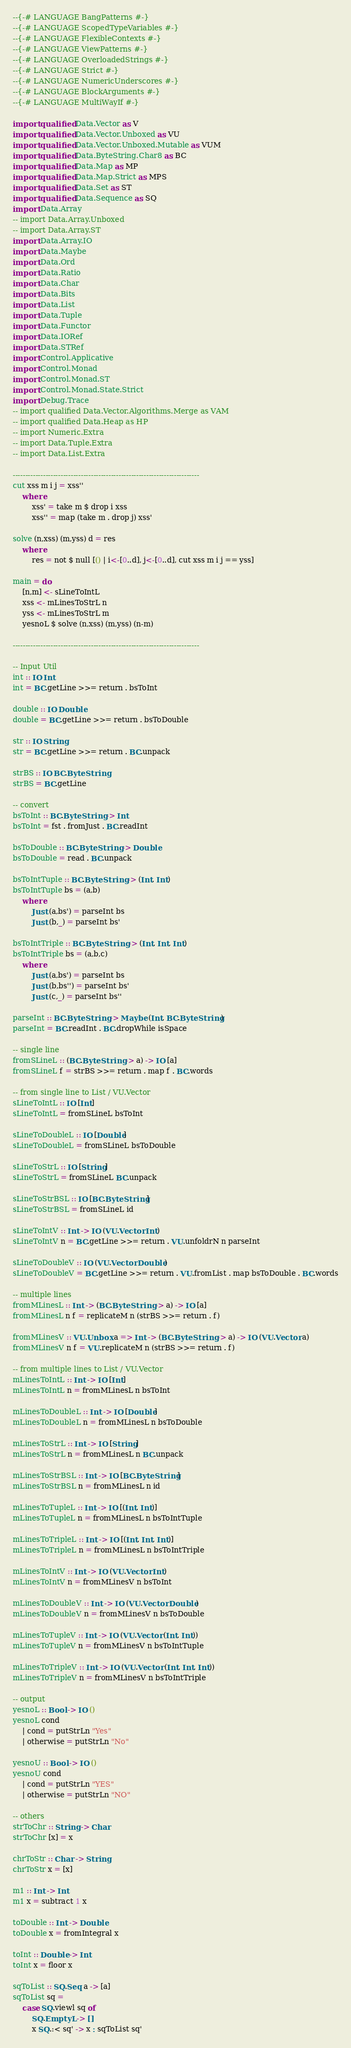<code> <loc_0><loc_0><loc_500><loc_500><_Haskell_>--{-# LANGUAGE BangPatterns #-}
--{-# LANGUAGE ScopedTypeVariables #-}
--{-# LANGUAGE FlexibleContexts #-}
--{-# LANGUAGE ViewPatterns #-}
--{-# LANGUAGE OverloadedStrings #-}
--{-# LANGUAGE Strict #-}
--{-# LANGUAGE NumericUnderscores #-}
--{-# LANGUAGE BlockArguments #-}
--{-# LANGUAGE MultiWayIf #-}

import qualified Data.Vector as V
import qualified Data.Vector.Unboxed as VU
import qualified Data.Vector.Unboxed.Mutable as VUM
import qualified Data.ByteString.Char8 as BC
import qualified Data.Map as MP
import qualified Data.Map.Strict as MPS
import qualified Data.Set as ST
import qualified Data.Sequence as SQ
import Data.Array
-- import Data.Array.Unboxed
-- import Data.Array.ST
import Data.Array.IO
import Data.Maybe
import Data.Ord
import Data.Ratio
import Data.Char
import Data.Bits
import Data.List
import Data.Tuple
import Data.Functor
import Data.IORef
import Data.STRef
import Control.Applicative
import Control.Monad
import Control.Monad.ST
import Control.Monad.State.Strict
import Debug.Trace
-- import qualified Data.Vector.Algorithms.Merge as VAM
-- import qualified Data.Heap as HP
-- import Numeric.Extra
-- import Data.Tuple.Extra
-- import Data.List.Extra

--------------------------------------------------------------------------
cut xss m i j = xss''
    where
        xss' = take m $ drop i xss
        xss'' = map (take m . drop j) xss'

solve (n,xss) (m,yss) d = res
    where
        res = not $ null [() | i<-[0..d], j<-[0..d], cut xss m i j == yss]

main = do
    [n,m] <- sLineToIntL
    xss <- mLinesToStrL n
    yss <- mLinesToStrL m
    yesnoL $ solve (n,xss) (m,yss) (n-m)
    
--------------------------------------------------------------------------

-- Input Util
int :: IO Int
int = BC.getLine >>= return . bsToInt

double :: IO Double
double = BC.getLine >>= return . bsToDouble

str :: IO String
str = BC.getLine >>= return . BC.unpack

strBS :: IO BC.ByteString
strBS = BC.getLine

-- convert
bsToInt :: BC.ByteString -> Int
bsToInt = fst . fromJust . BC.readInt

bsToDouble :: BC.ByteString -> Double
bsToDouble = read . BC.unpack

bsToIntTuple :: BC.ByteString -> (Int, Int)
bsToIntTuple bs = (a,b)
    where
        Just (a,bs') = parseInt bs
        Just (b,_) = parseInt bs'

bsToIntTriple :: BC.ByteString -> (Int, Int, Int)
bsToIntTriple bs = (a,b,c)
    where
        Just (a,bs') = parseInt bs
        Just (b,bs'') = parseInt bs'
        Just (c,_) = parseInt bs''

parseInt :: BC.ByteString -> Maybe (Int, BC.ByteString)
parseInt = BC.readInt . BC.dropWhile isSpace

-- single line
fromSLineL :: (BC.ByteString -> a) -> IO [a]
fromSLineL f = strBS >>= return . map f . BC.words

-- from single line to List / VU.Vector 
sLineToIntL :: IO [Int]
sLineToIntL = fromSLineL bsToInt

sLineToDoubleL :: IO [Double]
sLineToDoubleL = fromSLineL bsToDouble

sLineToStrL :: IO [String]
sLineToStrL = fromSLineL BC.unpack

sLineToStrBSL :: IO [BC.ByteString]
sLineToStrBSL = fromSLineL id 

sLineToIntV :: Int -> IO (VU.Vector Int)
sLineToIntV n = BC.getLine >>= return . VU.unfoldrN n parseInt

sLineToDoubleV :: IO (VU.Vector Double)
sLineToDoubleV = BC.getLine >>= return . VU.fromList . map bsToDouble . BC.words

-- multiple lines
fromMLinesL :: Int -> (BC.ByteString -> a) -> IO [a]
fromMLinesL n f = replicateM n (strBS >>= return . f)

fromMLinesV :: VU.Unbox a => Int -> (BC.ByteString -> a) -> IO (VU.Vector a)
fromMLinesV n f = VU.replicateM n (strBS >>= return . f)

-- from multiple lines to List / VU.Vector
mLinesToIntL :: Int -> IO [Int]
mLinesToIntL n = fromMLinesL n bsToInt

mLinesToDoubleL :: Int -> IO [Double]
mLinesToDoubleL n = fromMLinesL n bsToDouble

mLinesToStrL :: Int -> IO [String]
mLinesToStrL n = fromMLinesL n BC.unpack

mLinesToStrBSL :: Int -> IO [BC.ByteString]
mLinesToStrBSL n = fromMLinesL n id

mLinesToTupleL :: Int -> IO [(Int, Int)]
mLinesToTupleL n = fromMLinesL n bsToIntTuple

mLinesToTripleL :: Int -> IO [(Int, Int, Int)]
mLinesToTripleL n = fromMLinesL n bsToIntTriple

mLinesToIntV :: Int -> IO (VU.Vector Int)
mLinesToIntV n = fromMLinesV n bsToInt

mLinesToDoubleV :: Int -> IO (VU.Vector Double)
mLinesToDoubleV n = fromMLinesV n bsToDouble

mLinesToTupleV :: Int -> IO (VU.Vector (Int, Int))
mLinesToTupleV n = fromMLinesV n bsToIntTuple
    
mLinesToTripleV :: Int -> IO (VU.Vector (Int, Int, Int))
mLinesToTripleV n = fromMLinesV n bsToIntTriple

-- output
yesnoL :: Bool -> IO ()
yesnoL cond
    | cond = putStrLn "Yes"
    | otherwise = putStrLn "No"

yesnoU :: Bool -> IO ()
yesnoU cond
    | cond = putStrLn "YES"
    | otherwise = putStrLn "NO"

-- others
strToChr :: String -> Char
strToChr [x] = x

chrToStr :: Char -> String
chrToStr x = [x]

m1 :: Int -> Int
m1 x = subtract 1 x

toDouble :: Int -> Double
toDouble x = fromIntegral x

toInt :: Double -> Int
toInt x = floor x

sqToList :: SQ.Seq a -> [a]
sqToList sq = 
    case SQ.viewl sq of
        SQ.EmptyL -> []
        x SQ.:< sq' -> x : sqToList sq'
</code> 